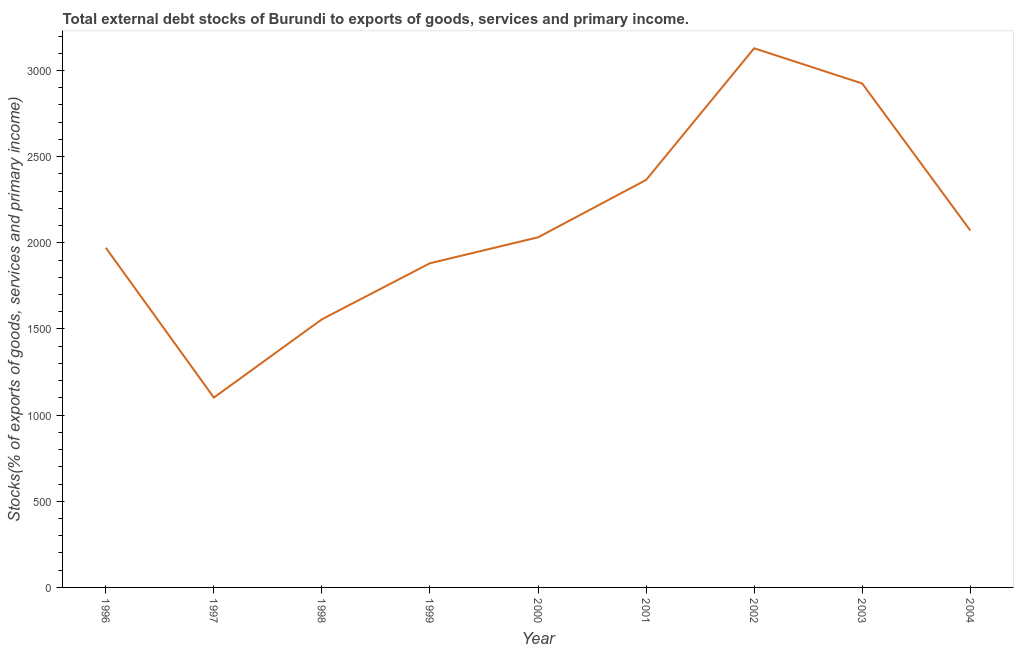What is the external debt stocks in 1996?
Provide a short and direct response. 1971.54. Across all years, what is the maximum external debt stocks?
Make the answer very short. 3128.96. Across all years, what is the minimum external debt stocks?
Provide a short and direct response. 1101.81. In which year was the external debt stocks maximum?
Provide a succinct answer. 2002. What is the sum of the external debt stocks?
Make the answer very short. 1.90e+04. What is the difference between the external debt stocks in 1998 and 1999?
Offer a terse response. -325.38. What is the average external debt stocks per year?
Make the answer very short. 2114.8. What is the median external debt stocks?
Offer a very short reply. 2031.87. Do a majority of the years between 1996 and 2002 (inclusive) have external debt stocks greater than 200 %?
Keep it short and to the point. Yes. What is the ratio of the external debt stocks in 1996 to that in 1998?
Make the answer very short. 1.27. Is the external debt stocks in 1998 less than that in 2004?
Give a very brief answer. Yes. What is the difference between the highest and the second highest external debt stocks?
Your answer should be very brief. 204.21. Is the sum of the external debt stocks in 2001 and 2003 greater than the maximum external debt stocks across all years?
Offer a terse response. Yes. What is the difference between the highest and the lowest external debt stocks?
Offer a terse response. 2027.15. In how many years, is the external debt stocks greater than the average external debt stocks taken over all years?
Provide a succinct answer. 3. Does the external debt stocks monotonically increase over the years?
Offer a terse response. No. How many years are there in the graph?
Provide a short and direct response. 9. What is the difference between two consecutive major ticks on the Y-axis?
Your answer should be very brief. 500. Does the graph contain grids?
Offer a very short reply. No. What is the title of the graph?
Give a very brief answer. Total external debt stocks of Burundi to exports of goods, services and primary income. What is the label or title of the X-axis?
Offer a terse response. Year. What is the label or title of the Y-axis?
Your answer should be compact. Stocks(% of exports of goods, services and primary income). What is the Stocks(% of exports of goods, services and primary income) of 1996?
Offer a terse response. 1971.54. What is the Stocks(% of exports of goods, services and primary income) of 1997?
Offer a very short reply. 1101.81. What is the Stocks(% of exports of goods, services and primary income) in 1998?
Offer a terse response. 1556.17. What is the Stocks(% of exports of goods, services and primary income) of 1999?
Offer a terse response. 1881.55. What is the Stocks(% of exports of goods, services and primary income) of 2000?
Provide a short and direct response. 2031.87. What is the Stocks(% of exports of goods, services and primary income) of 2001?
Your answer should be compact. 2364.89. What is the Stocks(% of exports of goods, services and primary income) in 2002?
Offer a terse response. 3128.96. What is the Stocks(% of exports of goods, services and primary income) of 2003?
Make the answer very short. 2924.74. What is the Stocks(% of exports of goods, services and primary income) of 2004?
Your response must be concise. 2071.68. What is the difference between the Stocks(% of exports of goods, services and primary income) in 1996 and 1997?
Keep it short and to the point. 869.73. What is the difference between the Stocks(% of exports of goods, services and primary income) in 1996 and 1998?
Provide a succinct answer. 415.36. What is the difference between the Stocks(% of exports of goods, services and primary income) in 1996 and 1999?
Keep it short and to the point. 89.98. What is the difference between the Stocks(% of exports of goods, services and primary income) in 1996 and 2000?
Give a very brief answer. -60.34. What is the difference between the Stocks(% of exports of goods, services and primary income) in 1996 and 2001?
Provide a short and direct response. -393.35. What is the difference between the Stocks(% of exports of goods, services and primary income) in 1996 and 2002?
Your answer should be very brief. -1157.42. What is the difference between the Stocks(% of exports of goods, services and primary income) in 1996 and 2003?
Your answer should be very brief. -953.21. What is the difference between the Stocks(% of exports of goods, services and primary income) in 1996 and 2004?
Keep it short and to the point. -100.15. What is the difference between the Stocks(% of exports of goods, services and primary income) in 1997 and 1998?
Your response must be concise. -454.36. What is the difference between the Stocks(% of exports of goods, services and primary income) in 1997 and 1999?
Offer a very short reply. -779.75. What is the difference between the Stocks(% of exports of goods, services and primary income) in 1997 and 2000?
Offer a very short reply. -930.07. What is the difference between the Stocks(% of exports of goods, services and primary income) in 1997 and 2001?
Your answer should be compact. -1263.08. What is the difference between the Stocks(% of exports of goods, services and primary income) in 1997 and 2002?
Make the answer very short. -2027.15. What is the difference between the Stocks(% of exports of goods, services and primary income) in 1997 and 2003?
Provide a short and direct response. -1822.94. What is the difference between the Stocks(% of exports of goods, services and primary income) in 1997 and 2004?
Make the answer very short. -969.88. What is the difference between the Stocks(% of exports of goods, services and primary income) in 1998 and 1999?
Your response must be concise. -325.38. What is the difference between the Stocks(% of exports of goods, services and primary income) in 1998 and 2000?
Offer a very short reply. -475.7. What is the difference between the Stocks(% of exports of goods, services and primary income) in 1998 and 2001?
Offer a terse response. -808.72. What is the difference between the Stocks(% of exports of goods, services and primary income) in 1998 and 2002?
Ensure brevity in your answer.  -1572.79. What is the difference between the Stocks(% of exports of goods, services and primary income) in 1998 and 2003?
Your response must be concise. -1368.57. What is the difference between the Stocks(% of exports of goods, services and primary income) in 1998 and 2004?
Offer a terse response. -515.51. What is the difference between the Stocks(% of exports of goods, services and primary income) in 1999 and 2000?
Make the answer very short. -150.32. What is the difference between the Stocks(% of exports of goods, services and primary income) in 1999 and 2001?
Provide a succinct answer. -483.34. What is the difference between the Stocks(% of exports of goods, services and primary income) in 1999 and 2002?
Your answer should be compact. -1247.41. What is the difference between the Stocks(% of exports of goods, services and primary income) in 1999 and 2003?
Offer a very short reply. -1043.19. What is the difference between the Stocks(% of exports of goods, services and primary income) in 1999 and 2004?
Make the answer very short. -190.13. What is the difference between the Stocks(% of exports of goods, services and primary income) in 2000 and 2001?
Give a very brief answer. -333.02. What is the difference between the Stocks(% of exports of goods, services and primary income) in 2000 and 2002?
Give a very brief answer. -1097.09. What is the difference between the Stocks(% of exports of goods, services and primary income) in 2000 and 2003?
Your answer should be very brief. -892.87. What is the difference between the Stocks(% of exports of goods, services and primary income) in 2000 and 2004?
Give a very brief answer. -39.81. What is the difference between the Stocks(% of exports of goods, services and primary income) in 2001 and 2002?
Give a very brief answer. -764.07. What is the difference between the Stocks(% of exports of goods, services and primary income) in 2001 and 2003?
Provide a short and direct response. -559.86. What is the difference between the Stocks(% of exports of goods, services and primary income) in 2001 and 2004?
Your answer should be compact. 293.21. What is the difference between the Stocks(% of exports of goods, services and primary income) in 2002 and 2003?
Your answer should be very brief. 204.21. What is the difference between the Stocks(% of exports of goods, services and primary income) in 2002 and 2004?
Keep it short and to the point. 1057.28. What is the difference between the Stocks(% of exports of goods, services and primary income) in 2003 and 2004?
Ensure brevity in your answer.  853.06. What is the ratio of the Stocks(% of exports of goods, services and primary income) in 1996 to that in 1997?
Make the answer very short. 1.79. What is the ratio of the Stocks(% of exports of goods, services and primary income) in 1996 to that in 1998?
Offer a very short reply. 1.27. What is the ratio of the Stocks(% of exports of goods, services and primary income) in 1996 to that in 1999?
Offer a terse response. 1.05. What is the ratio of the Stocks(% of exports of goods, services and primary income) in 1996 to that in 2001?
Give a very brief answer. 0.83. What is the ratio of the Stocks(% of exports of goods, services and primary income) in 1996 to that in 2002?
Your answer should be compact. 0.63. What is the ratio of the Stocks(% of exports of goods, services and primary income) in 1996 to that in 2003?
Your answer should be compact. 0.67. What is the ratio of the Stocks(% of exports of goods, services and primary income) in 1997 to that in 1998?
Keep it short and to the point. 0.71. What is the ratio of the Stocks(% of exports of goods, services and primary income) in 1997 to that in 1999?
Your answer should be compact. 0.59. What is the ratio of the Stocks(% of exports of goods, services and primary income) in 1997 to that in 2000?
Offer a very short reply. 0.54. What is the ratio of the Stocks(% of exports of goods, services and primary income) in 1997 to that in 2001?
Provide a succinct answer. 0.47. What is the ratio of the Stocks(% of exports of goods, services and primary income) in 1997 to that in 2002?
Provide a short and direct response. 0.35. What is the ratio of the Stocks(% of exports of goods, services and primary income) in 1997 to that in 2003?
Give a very brief answer. 0.38. What is the ratio of the Stocks(% of exports of goods, services and primary income) in 1997 to that in 2004?
Offer a terse response. 0.53. What is the ratio of the Stocks(% of exports of goods, services and primary income) in 1998 to that in 1999?
Ensure brevity in your answer.  0.83. What is the ratio of the Stocks(% of exports of goods, services and primary income) in 1998 to that in 2000?
Keep it short and to the point. 0.77. What is the ratio of the Stocks(% of exports of goods, services and primary income) in 1998 to that in 2001?
Make the answer very short. 0.66. What is the ratio of the Stocks(% of exports of goods, services and primary income) in 1998 to that in 2002?
Your answer should be compact. 0.5. What is the ratio of the Stocks(% of exports of goods, services and primary income) in 1998 to that in 2003?
Make the answer very short. 0.53. What is the ratio of the Stocks(% of exports of goods, services and primary income) in 1998 to that in 2004?
Keep it short and to the point. 0.75. What is the ratio of the Stocks(% of exports of goods, services and primary income) in 1999 to that in 2000?
Keep it short and to the point. 0.93. What is the ratio of the Stocks(% of exports of goods, services and primary income) in 1999 to that in 2001?
Offer a terse response. 0.8. What is the ratio of the Stocks(% of exports of goods, services and primary income) in 1999 to that in 2002?
Provide a succinct answer. 0.6. What is the ratio of the Stocks(% of exports of goods, services and primary income) in 1999 to that in 2003?
Offer a very short reply. 0.64. What is the ratio of the Stocks(% of exports of goods, services and primary income) in 1999 to that in 2004?
Offer a terse response. 0.91. What is the ratio of the Stocks(% of exports of goods, services and primary income) in 2000 to that in 2001?
Your response must be concise. 0.86. What is the ratio of the Stocks(% of exports of goods, services and primary income) in 2000 to that in 2002?
Provide a short and direct response. 0.65. What is the ratio of the Stocks(% of exports of goods, services and primary income) in 2000 to that in 2003?
Your answer should be very brief. 0.69. What is the ratio of the Stocks(% of exports of goods, services and primary income) in 2000 to that in 2004?
Ensure brevity in your answer.  0.98. What is the ratio of the Stocks(% of exports of goods, services and primary income) in 2001 to that in 2002?
Offer a terse response. 0.76. What is the ratio of the Stocks(% of exports of goods, services and primary income) in 2001 to that in 2003?
Give a very brief answer. 0.81. What is the ratio of the Stocks(% of exports of goods, services and primary income) in 2001 to that in 2004?
Your answer should be very brief. 1.14. What is the ratio of the Stocks(% of exports of goods, services and primary income) in 2002 to that in 2003?
Offer a very short reply. 1.07. What is the ratio of the Stocks(% of exports of goods, services and primary income) in 2002 to that in 2004?
Keep it short and to the point. 1.51. What is the ratio of the Stocks(% of exports of goods, services and primary income) in 2003 to that in 2004?
Give a very brief answer. 1.41. 